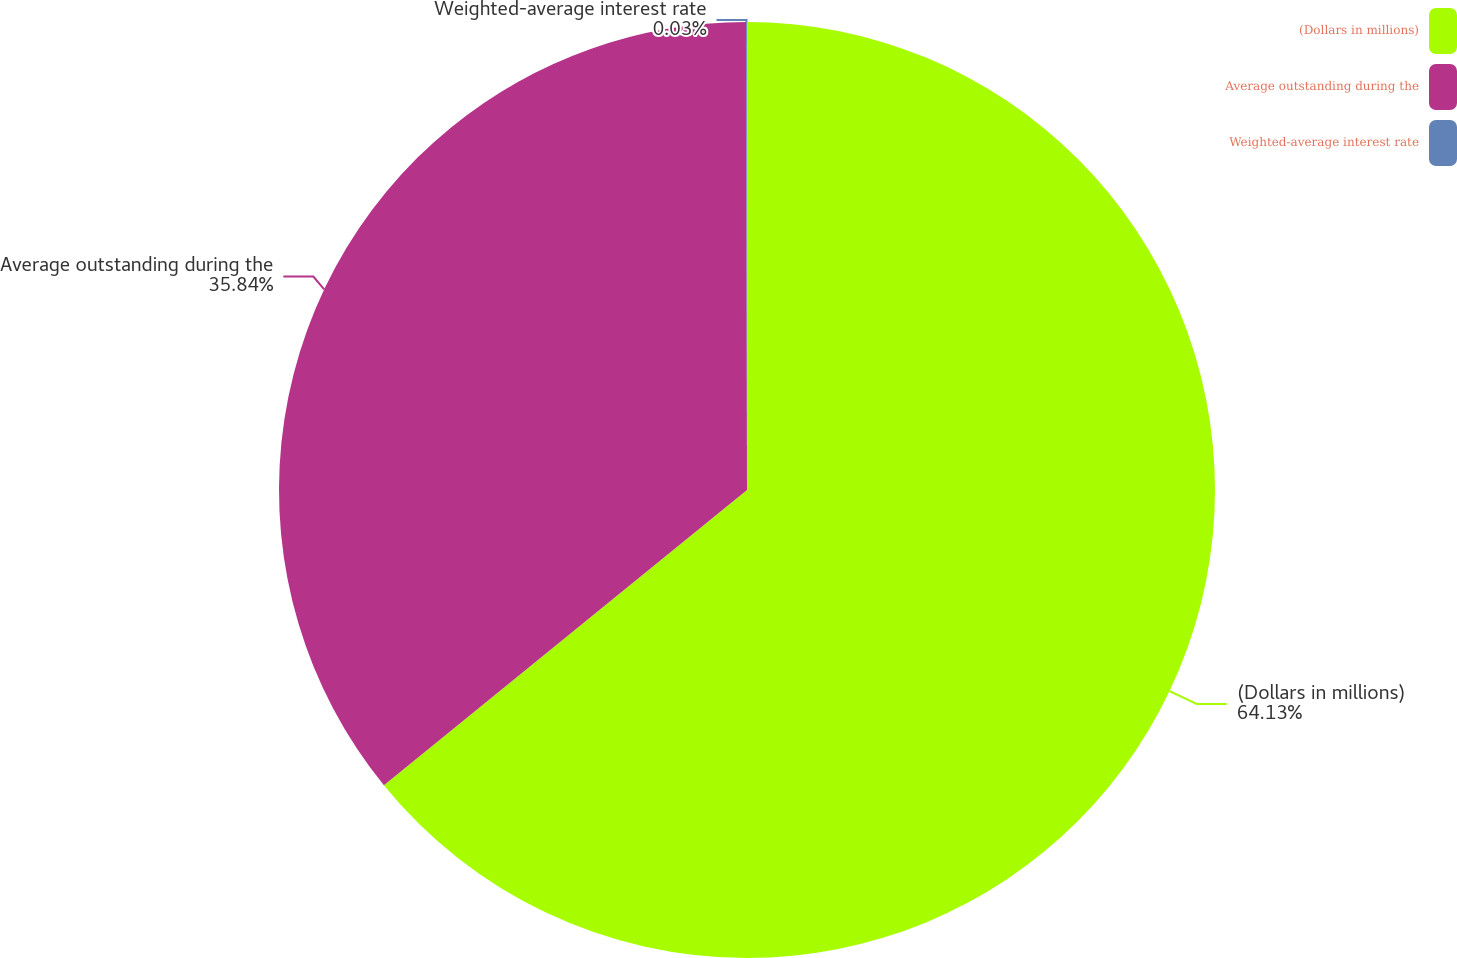<chart> <loc_0><loc_0><loc_500><loc_500><pie_chart><fcel>(Dollars in millions)<fcel>Average outstanding during the<fcel>Weighted-average interest rate<nl><fcel>64.14%<fcel>35.84%<fcel>0.03%<nl></chart> 